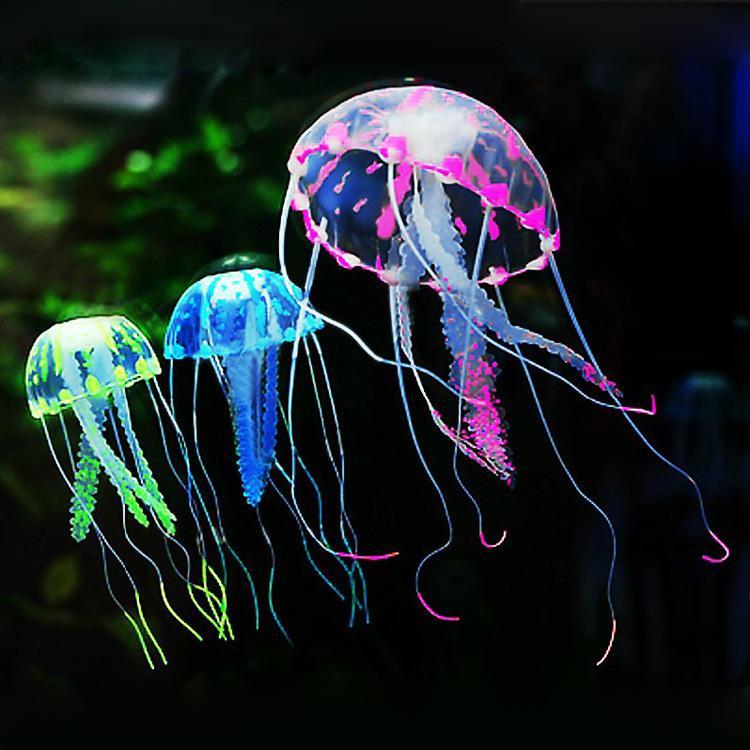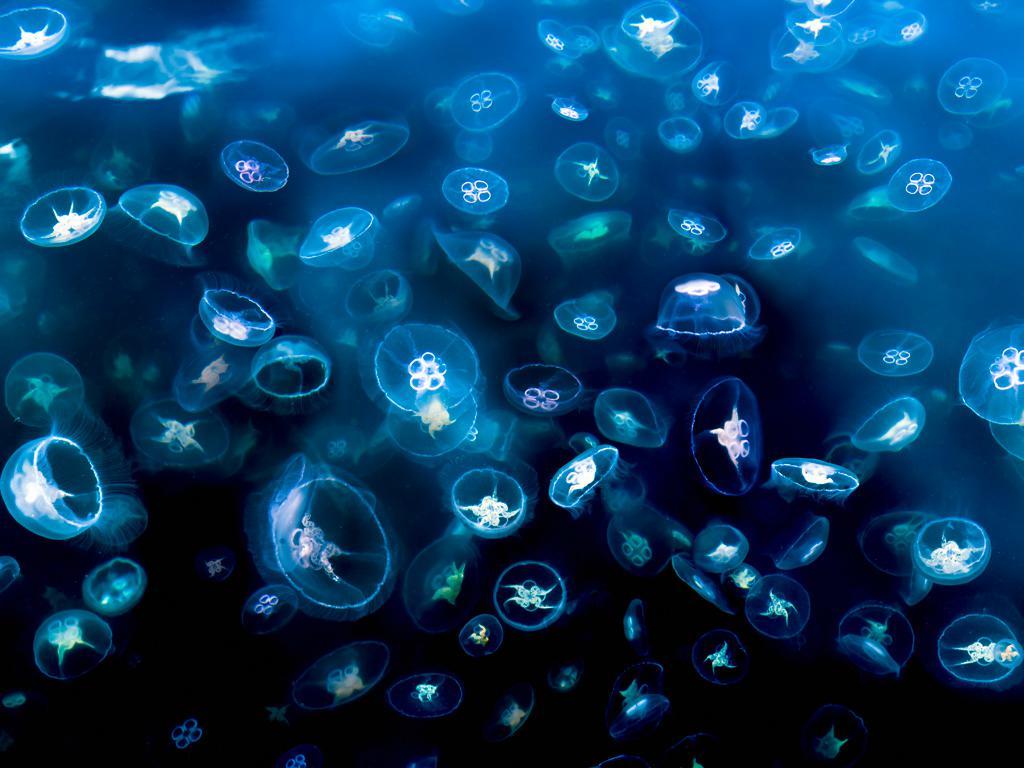The first image is the image on the left, the second image is the image on the right. Assess this claim about the two images: "Each image features different colors of jellyfish with long tentacles dangling downward, and the right image features jellyfish in an aquarium tank with green plants.". Correct or not? Answer yes or no. No. The first image is the image on the left, the second image is the image on the right. Examine the images to the left and right. Is the description "One image in the pair shows jellyfish of all one color while the other shows jellyfish in a variety of colors." accurate? Answer yes or no. Yes. 